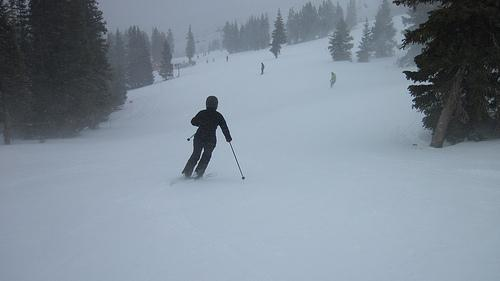What is the overarching theme of this image, and what elements can be observed? The image depicts a winter ski scene, with a female skier wearing black jacket and pants, ski poles, ski lift, and snow-covered evergreen trees, all on a ski slope with bright white snow. How would you assess the quality of this image? The image is of good quality because it shows a clear winter scene with various details and well-defined objects. In the context of this image, identify the main activity, the environment, and overall weather conditions. The main activity is skiing, taking place on a ski slope surrounded by a forest of evergreen trees, during winter time with stormy weather and cold temperatures. Analyze the interaction between the skier and the environment. The skier engages with the environment by skiing on the snow-covered slope and navigating her way through evergreen trees. Briefly interpret the sentiment evoked by this image and why. The image evokes a sense of adventure and excitement, due to the skiing activity in a snowy winter landscape. Purpose of the ski poles in the skier's hands, and mention any other skiing equipment visible in the image. The ski poles provide balance and support to the skier during skiing, and other equipment includes a ski lift in the distance. Describe the attire of the female skier and her equipment. The female skier is wearing a black jacket and black pants, and she is holding two ski poles. Estimate the number of skiers in the image, and also mention their position on the ski slope. There are around five skiers, with one female skier as the main focus, and the others skiing past big trees at different distances. What type of trees are present in the image, and where are they situated in relation to the slope and the skier? There are evergreen trees, located on both the left and right sides of the slope, and many of them surrounding the skier. Talk about a unique aspect of the landscape in the image and any resulting visual effect. The bright white snow creates contrast with the surrounding trees and the skier's dark attire, resulting in a visually striking scene. 